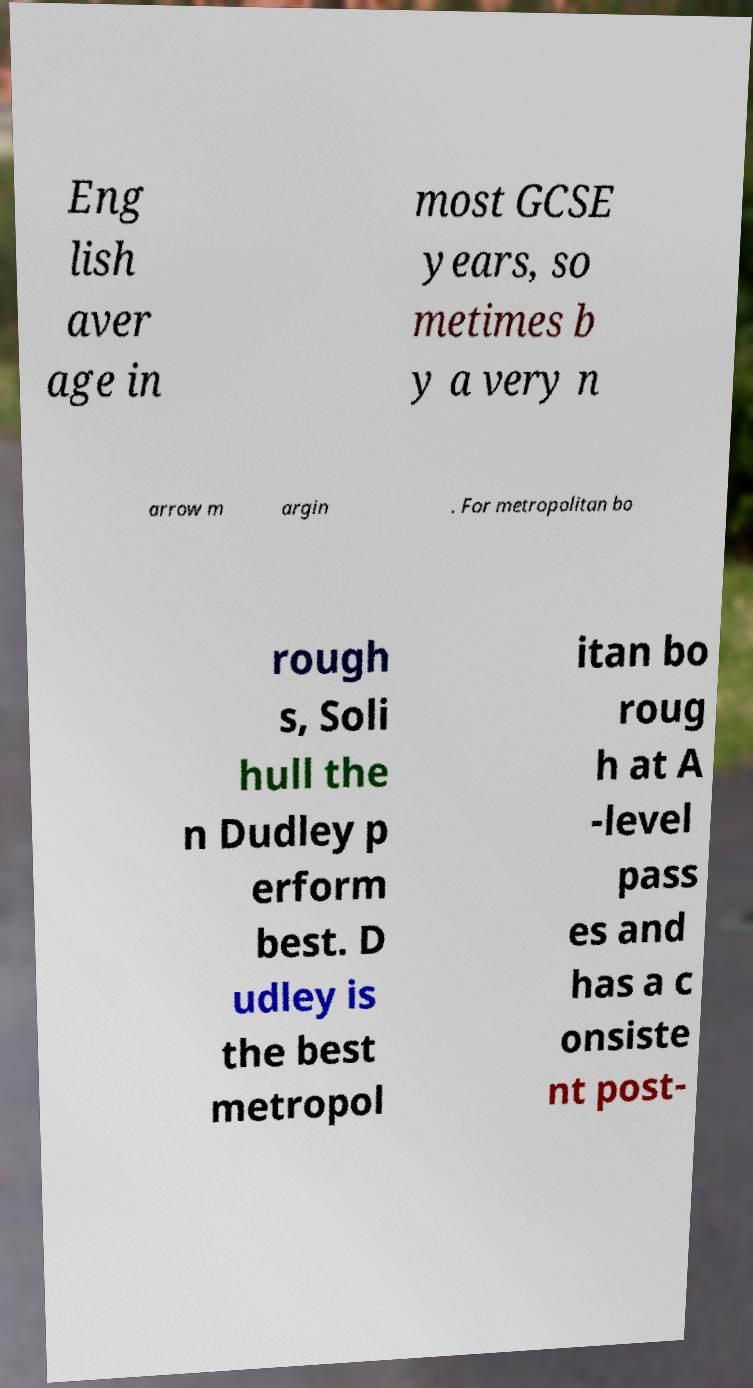Can you read and provide the text displayed in the image?This photo seems to have some interesting text. Can you extract and type it out for me? Eng lish aver age in most GCSE years, so metimes b y a very n arrow m argin . For metropolitan bo rough s, Soli hull the n Dudley p erform best. D udley is the best metropol itan bo roug h at A -level pass es and has a c onsiste nt post- 